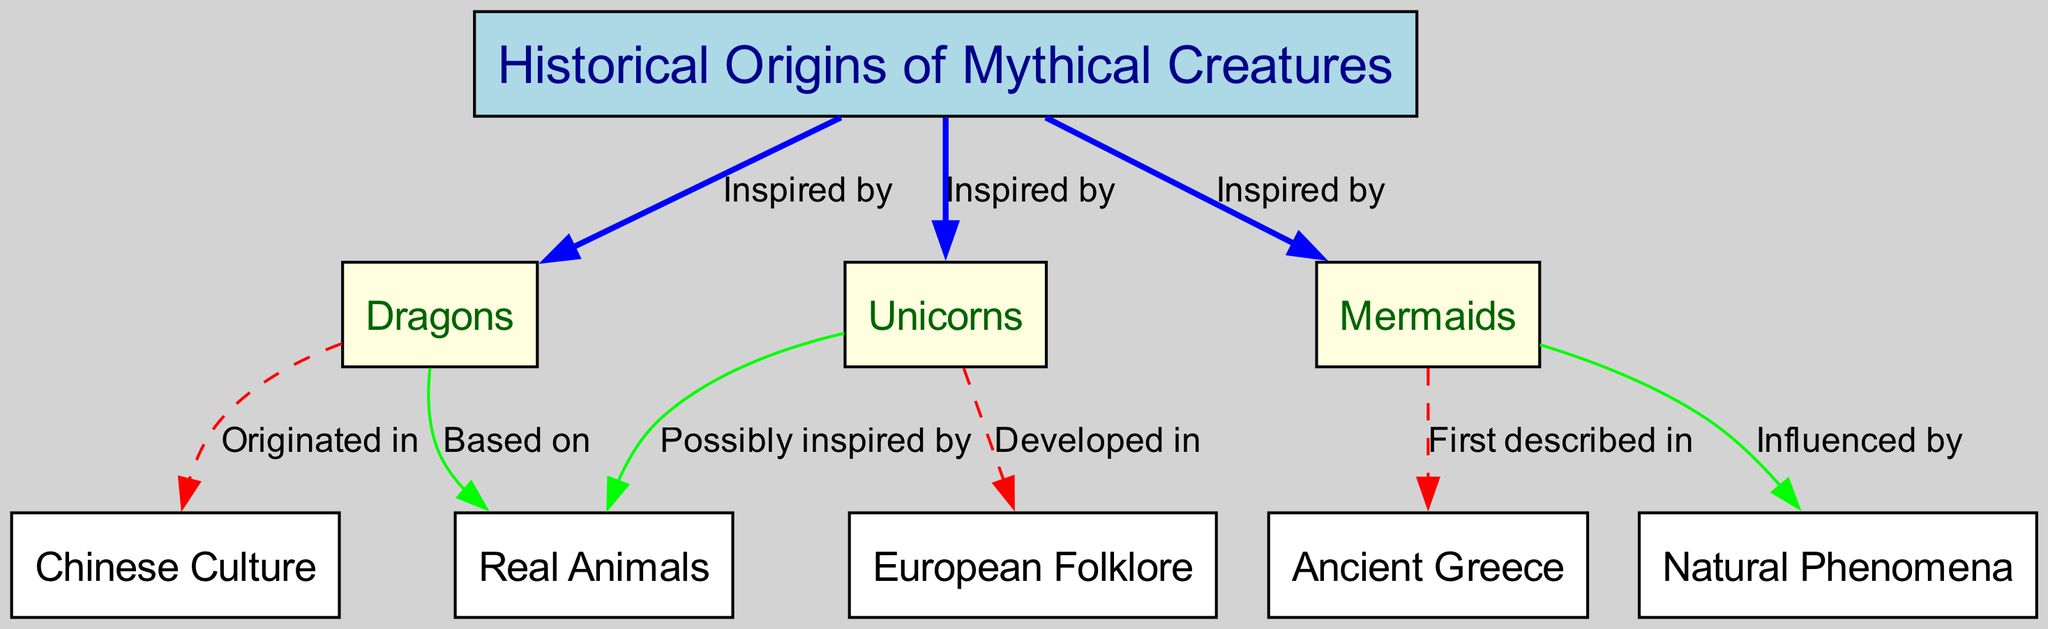What mythical creature is first described in ancient Greece? The diagram shows that mermaids are linked to ancient Greece with the label "First described in." This tells us that the mermaid is the mythical creature associated with this origin.
Answer: Mermaids How many mythical creatures are indicated in the diagram? The diagram lists three mythical creatures: dragons, unicorns, and mermaids. This is determined by counting the individual nodes categorized under mythical creatures.
Answer: 3 Where did unicorns develop? The connection between unicorns and the node labeled "European Folklore" indicates that this is where unicorns were developed. The edge labeled "Developed in" confirms this relationship.
Answer: European Folklore Which culture is dragons said to have originated in? The diagram shows an edge from dragons to "Chinese Culture" labeled "Originated in," which indicates that dragons have their origins in this particular culture.
Answer: Chinese Culture What are mermaids influenced by according to the diagram? The diagram indicates that mermaids are influenced by natural phenomena, as evidenced by the edge labeled "Influenced by" connecting mermaids to natural phenomena.
Answer: Natural Phenomena What real animals inspired unicorns? The edge labeled "Possibly inspired by" indicates the relationship between unicorns and real animals, suggesting that real animals served as inspiration for the concept of unicorns.
Answer: Real Animals What mythical creature is based on real animals? The edge from dragons to "Real Animals" with the label "Based on" implies that dragons are the mythical creatures inspired by real animals, as shown in the flow of the diagram.
Answer: Dragons How many edges connect mythical creatures to their origins? By examining the diagram, it is evident that there are three edges directly connecting mythical creatures to their origins: dragons to Chinese Culture, unicorns to European Folklore, and mermaids to Ancient Greece, indicating a total of three connections.
Answer: 3 What is the relationship between mermaids and natural phenomena? The diagram displays that mermaids are influenced by natural phenomena, as indicated by the edge connecting the two nodes labeled "Influenced by." This signifies a direct relationship where natural phenomena impact the concept of mermaids.
Answer: Influenced by 